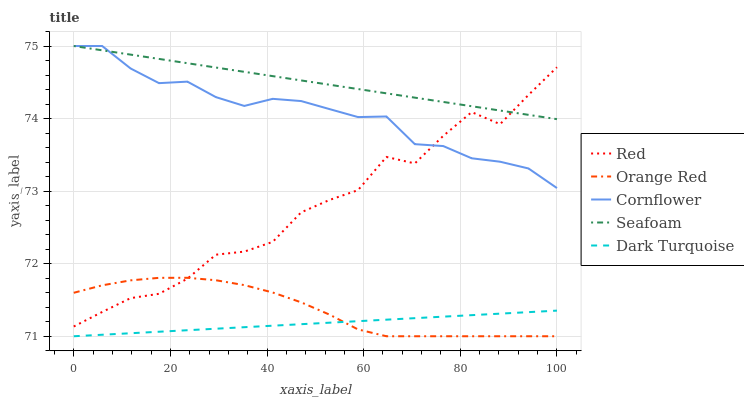Does Orange Red have the minimum area under the curve?
Answer yes or no. No. Does Orange Red have the maximum area under the curve?
Answer yes or no. No. Is Orange Red the smoothest?
Answer yes or no. No. Is Orange Red the roughest?
Answer yes or no. No. Does Red have the lowest value?
Answer yes or no. No. Does Orange Red have the highest value?
Answer yes or no. No. Is Dark Turquoise less than Seafoam?
Answer yes or no. Yes. Is Cornflower greater than Orange Red?
Answer yes or no. Yes. Does Dark Turquoise intersect Seafoam?
Answer yes or no. No. 